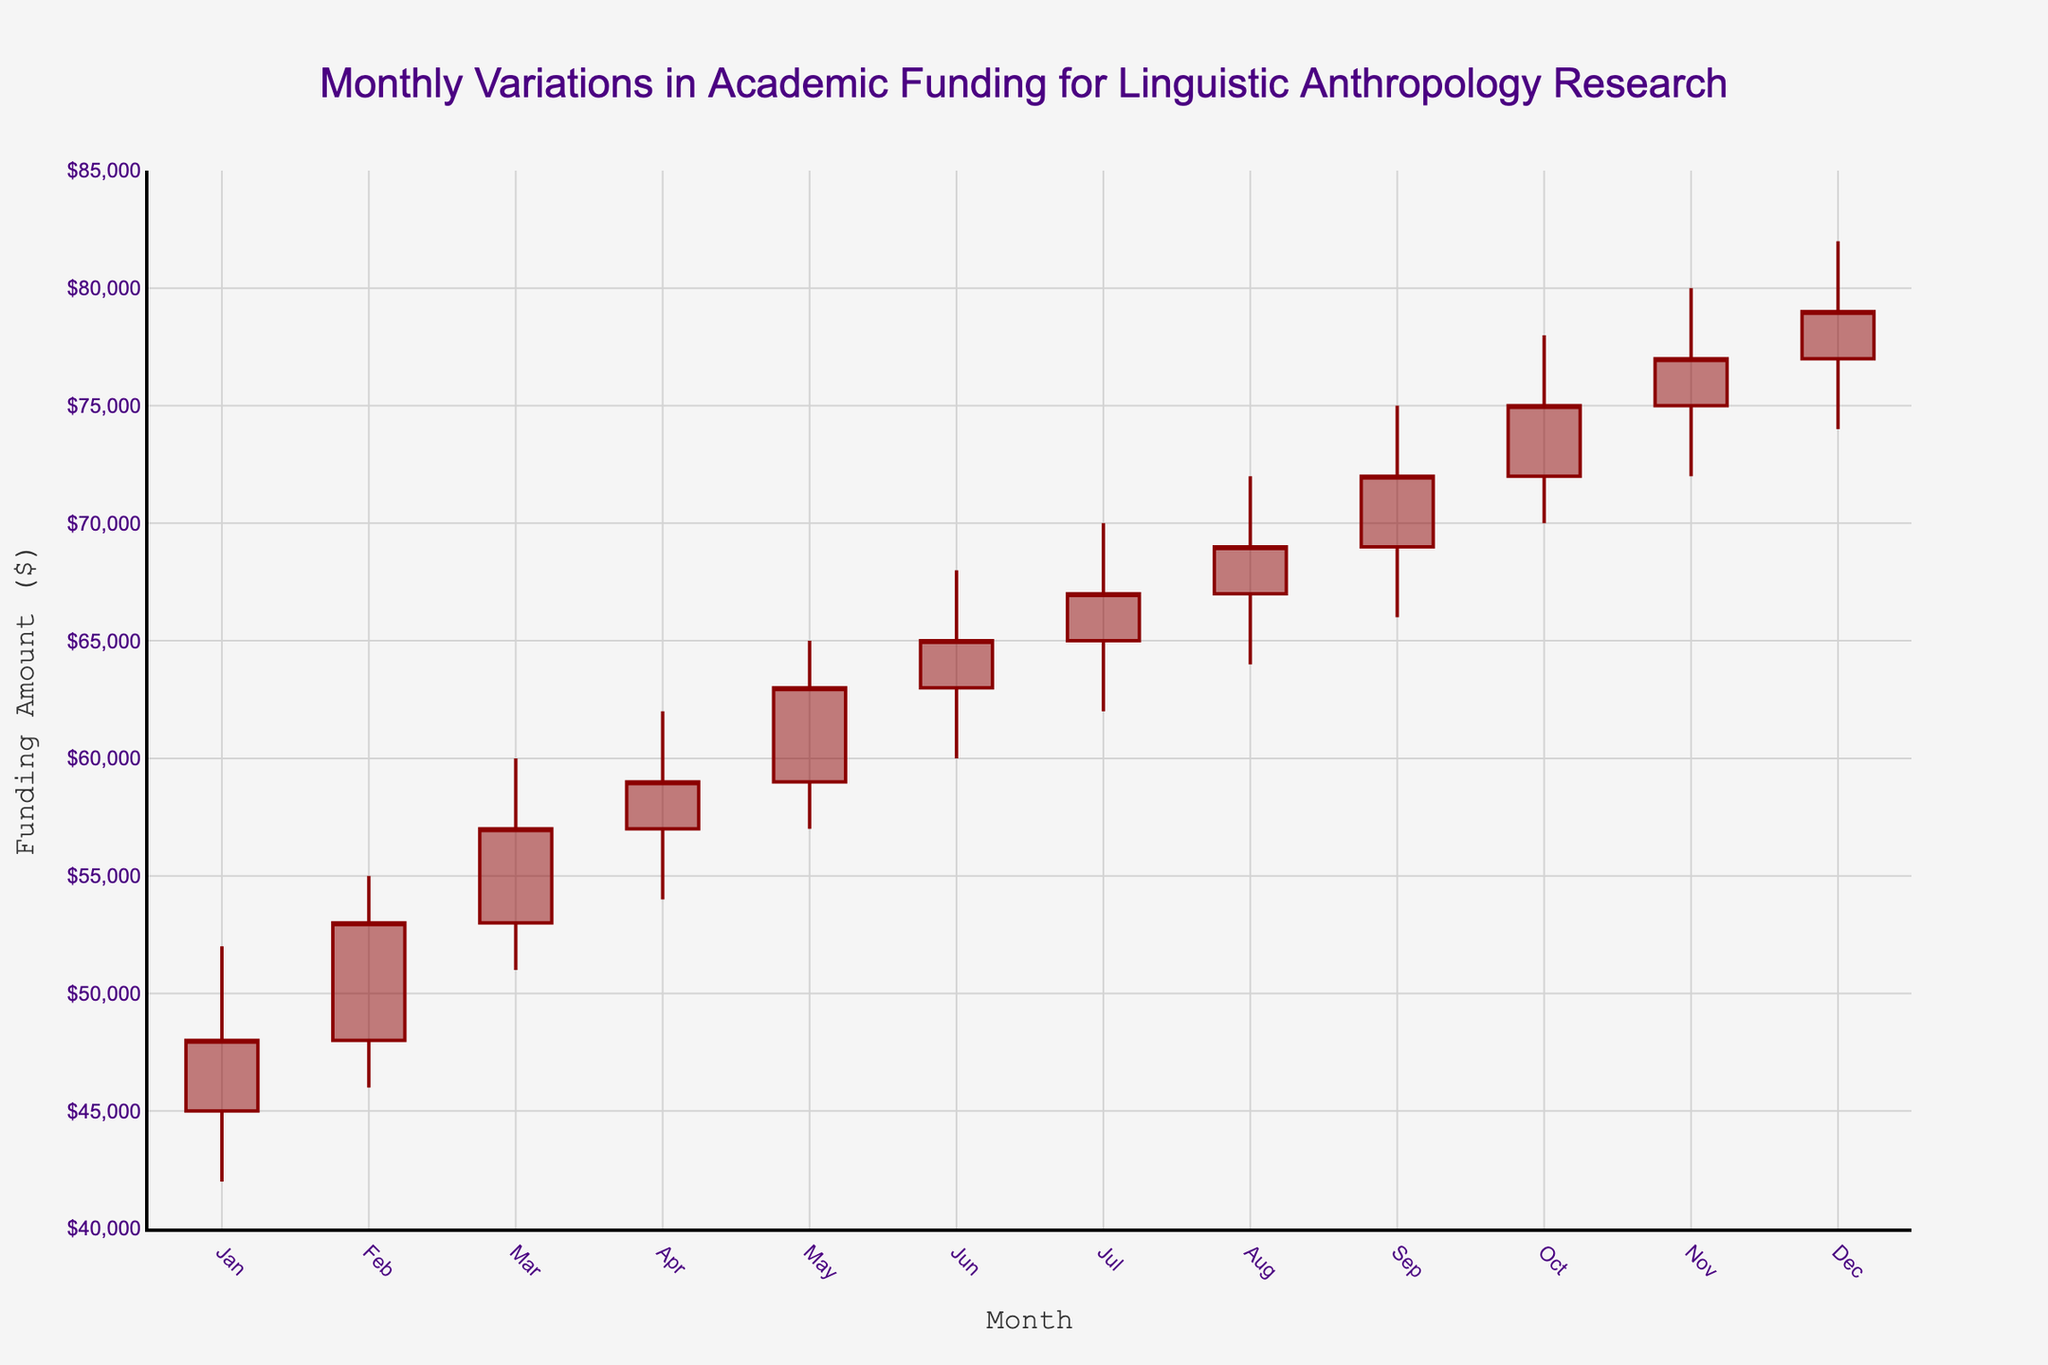What's the title of the chart? To find the title of the chart, look for the large text at the top of the figure. This is usually centered and formatted in a different color or size.
Answer: Monthly Variations in Academic Funding for Linguistic Anthropology Research What are the y-axis labels indicating? Y-axis labels usually represent the metric being measured. Below the y-axis, there's often a title clarifying what the numbers represent.
Answer: Funding Amount ($) Which month had the highest closing funding amount? To determine this, compare the closing funding amounts (the rightmost part of each candlestick) for all months and find the maximum value. The highest closing amount is 79000, which occurred in December.
Answer: December What is the low funding amount for June? Locate the candlestick representing June. The "low" value is usually shown by the lowest point of the candlestick's vertical line. The low value for June is 60000.
Answer: 60000 By how much did the closing funding amount increase from January to December? Subtract the closing amount of January (48000) from that of December (79000) to determine the increase. The increase is 79000 - 48000 = 31000.
Answer: 31000 Which month had the smallest range in funding amounts, and what was that range? The range is calculated by subtracting the low value from the high value for each month. Compare these ranges and identify the smallest one. April had the smallest range: 62000 - 54000 = 8000.
Answer: April, 8000 How many months had a closing funding amount greater than 70000? Count the months where the close value (the end of the candlestick) exceeds 70000. These months are September, October, November, and December, totaling 4.
Answer: 4 Which month shows the largest increase in funding within the month? The largest increase in funding within a month is found by comparing the difference between high and low values. October shows the highest fluctuation: 78000 - 70000 = 8000.
Answer: October What was the average closing funding amount for the year? Sum all closing funding amounts: 48000 + 53000 + 57000 + 59000 + 63000 + 65000 + 67000 + 69000 + 72000 + 75000 + 77000 + 79000 = 844000. Then divide by 12 to get the average: 844000 / 12 = 70333.33.
Answer: 70333.33 Which month saw the highest overall volatility in funding amounts? Volatility is indicated by the range of values for high and low. Compare the ranges for each month, where the highest range is from September: 75000 - 66000 = 9000.
Answer: September 